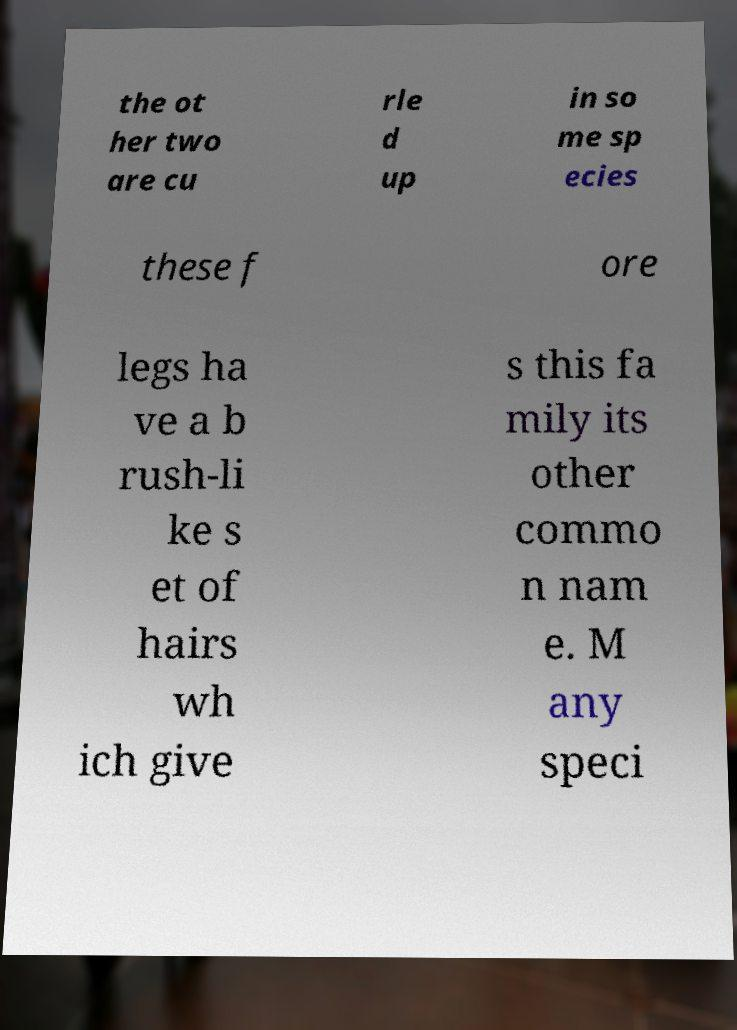There's text embedded in this image that I need extracted. Can you transcribe it verbatim? the ot her two are cu rle d up in so me sp ecies these f ore legs ha ve a b rush-li ke s et of hairs wh ich give s this fa mily its other commo n nam e. M any speci 